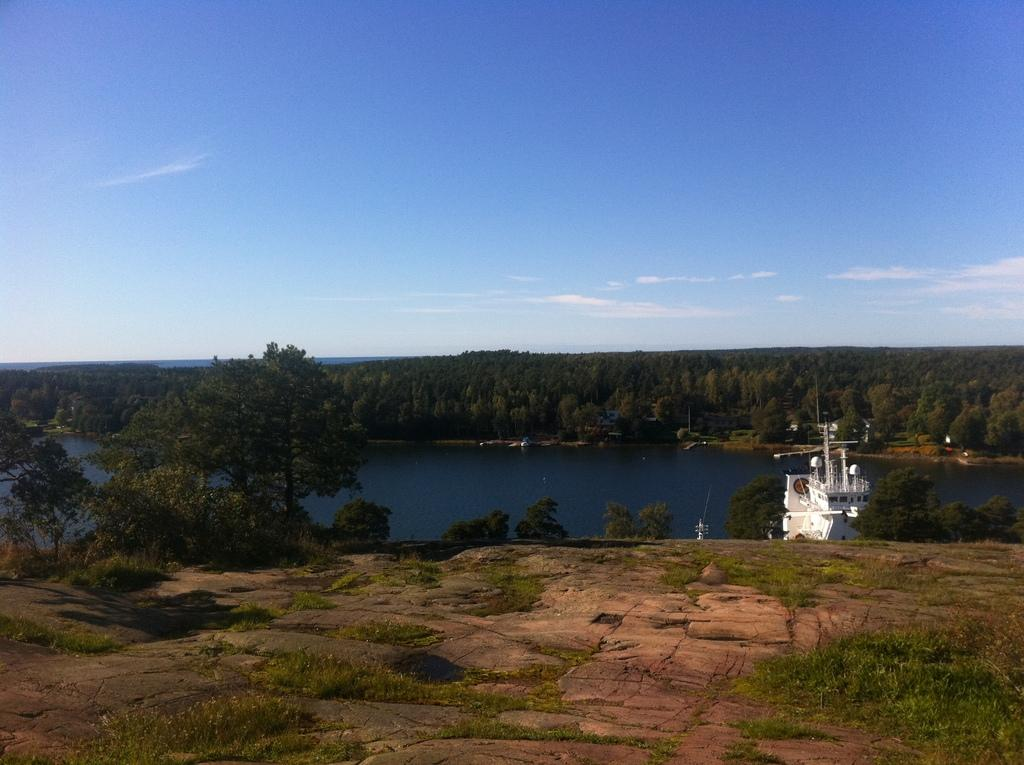What is the main subject of the image? The main subject of the image is a boat. Can you describe the boat in the image? The boat is white in color. What type of vegetation can be seen in the image? There are trees with branches and leaves in the image. What natural feature is present in the image? There is a river with water in the image. What part of the sky is visible in the image? The sky is visible in the image. Where is the coal pile located in the image? There is no coal pile present in the image. What type of pin can be seen holding the boat together in the image? The boat is a single, solid object in the image, and there are no pins visible. 